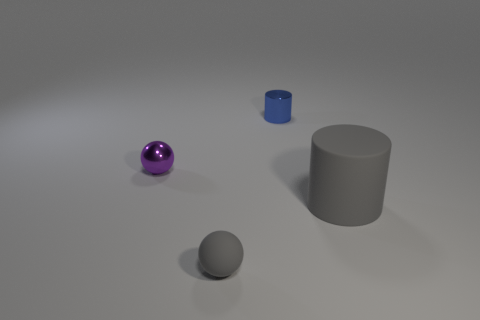How many big red objects are the same material as the small blue thing?
Ensure brevity in your answer.  0. Are there more tiny balls that are left of the tiny rubber object than large purple spheres?
Your answer should be very brief. Yes. There is a ball that is the same color as the large thing; what size is it?
Provide a succinct answer. Small. Is there a green object of the same shape as the blue thing?
Keep it short and to the point. No. How many things are green rubber objects or shiny cylinders?
Give a very brief answer. 1. What number of tiny shiny cylinders are in front of the cylinder in front of the shiny object that is in front of the blue cylinder?
Ensure brevity in your answer.  0. There is a small blue object that is the same shape as the large rubber thing; what is its material?
Provide a short and direct response. Metal. What is the material of the tiny thing that is behind the small gray rubber thing and to the right of the tiny purple metal sphere?
Your response must be concise. Metal. Are there fewer tiny blue things that are on the right side of the big rubber cylinder than small gray matte things that are in front of the small metallic sphere?
Ensure brevity in your answer.  Yes. How many other objects are the same size as the blue cylinder?
Provide a succinct answer. 2. 